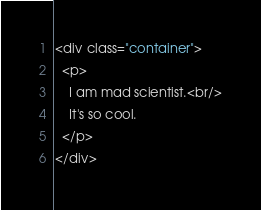<code> <loc_0><loc_0><loc_500><loc_500><_HTML_><div class="container">
  <p>
    I am mad scientist.<br/>
    It's so cool.
  </p>
</div></code> 